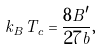Convert formula to latex. <formula><loc_0><loc_0><loc_500><loc_500>k _ { B } T _ { c } = \frac { 8 B ^ { \prime } } { 2 7 b } ,</formula> 